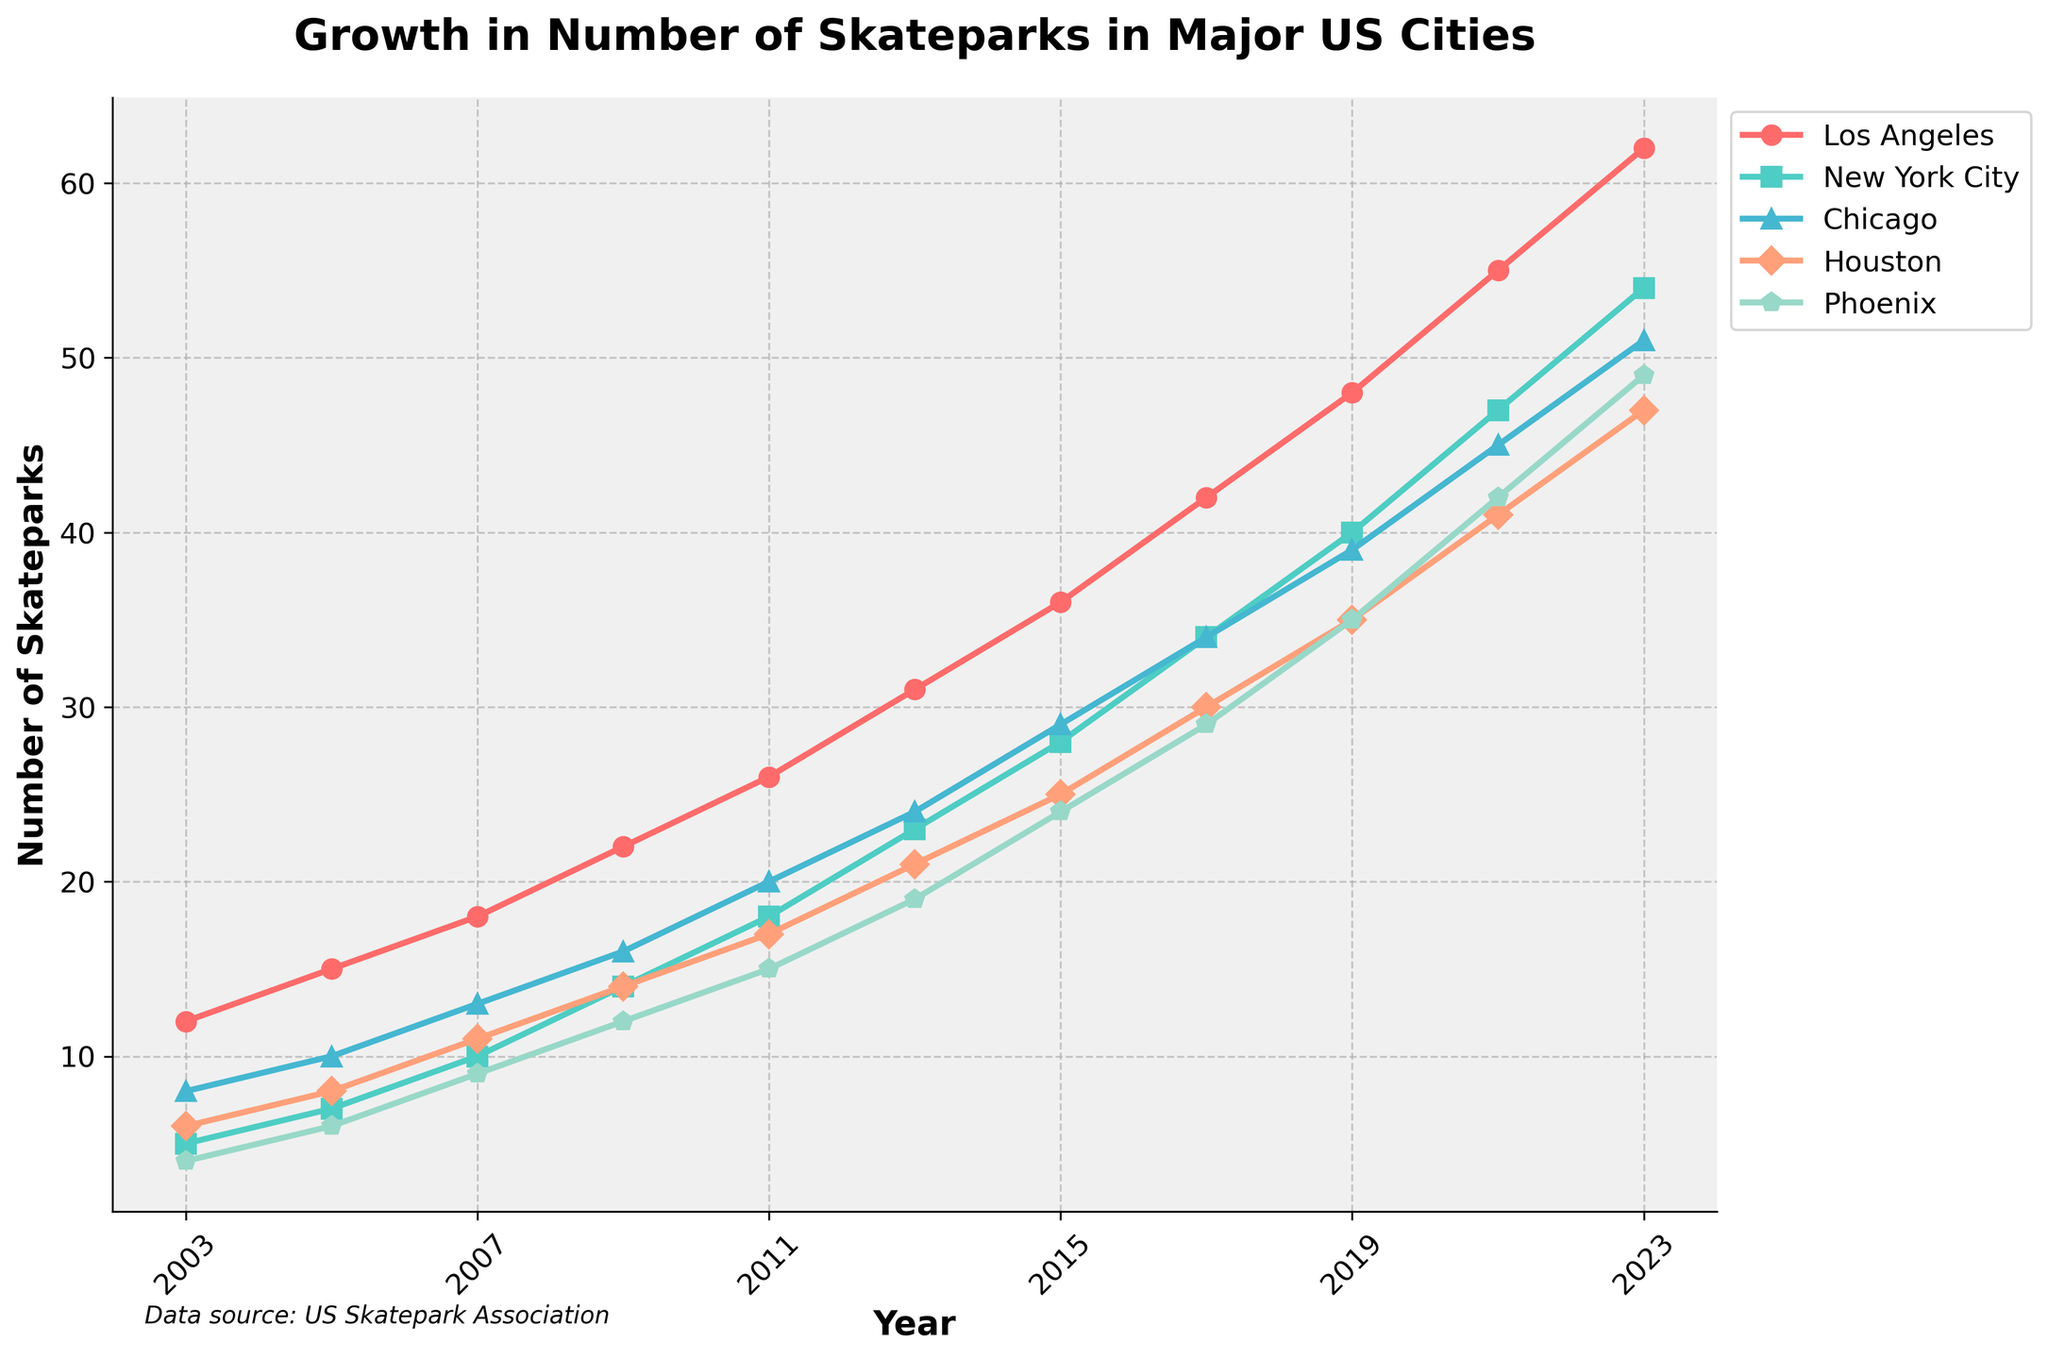What's the average number of skateparks in Los Angeles over the two decades? Sum the number of skateparks in Los Angeles for all the years (12 + 15 + 18 + 22 + 26 + 31 + 36 + 42 + 48 + 55 + 62) = 367. Then divide by the number of data points, which is 11. So, the average is 367 / 11.
Answer: 33.36 Which city had the highest growth in the number of skateparks between 2003 and 2023? Calculate the difference in the number of skateparks in each city between 2003 and 2023. Los Angeles: 62 - 12 = 50, New York City: 54 - 5 = 49, Chicago: 51 - 8 = 43, Houston: 47 - 6 = 41, Phoenix: 49 - 4 = 45. The highest growth is in Los Angeles, with 50.
Answer: Los Angeles In which year did New York City surpass Chicago in the number of skateparks? Compare the values for New York City and Chicago year by year. New York City surpasses Chicago between 2013 (23 vs 24) and 2015 (28 vs 29). Therefore, in 2015, New York City surpasses Chicago (28 vs 29).
Answer: 2015 What's the increase in the number of skateparks in Phoenix from 2009 to 2021? Subtract the number of skateparks in Phoenix in 2009 from the number in 2021. That is, 42 (2021) - 12 (2009) = 30.
Answer: 30 Which city had the least number of skateparks in 2017? Look at the data for 2017 across all cities: Los Angeles (42), New York City (34), Chicago (34), Houston (30), Phoenix (29). Phoenix has the least number of skateparks.
Answer: Phoenix How much did the number of skateparks in Houston change from 2005 to 2019? Calculate the difference in the number of skateparks in Houston between 2005 and 2019: 35 (2019) - 8 (2005) = 27.
Answer: 27 Which city had the closest number of skateparks to 40 in 2023? Compare the number of skateparks in 2023: Los Angeles (62), New York City (54), Chicago (51), Houston (47), Phoenix (49). Houston has the closest number to 40.
Answer: Houston Did any city's number of skateparks never decrease from one year to the next? Check year-by-year data for each city. All cities show an increase in the number of skateparks every year, so no city's number of skateparks decreased.
Answer: No city In which year did Los Angeles have more than double the number of skateparks compared to Phoenix? Compare Los Angeles' number of skateparks with twice the number of skateparks in Phoenix for each year. In 2017, Los Angeles (42) was more than double Phoenix (29 x 2 = 58), similarly for 2019, and onwards. The year this first happens is 2017.
Answer: 2017 